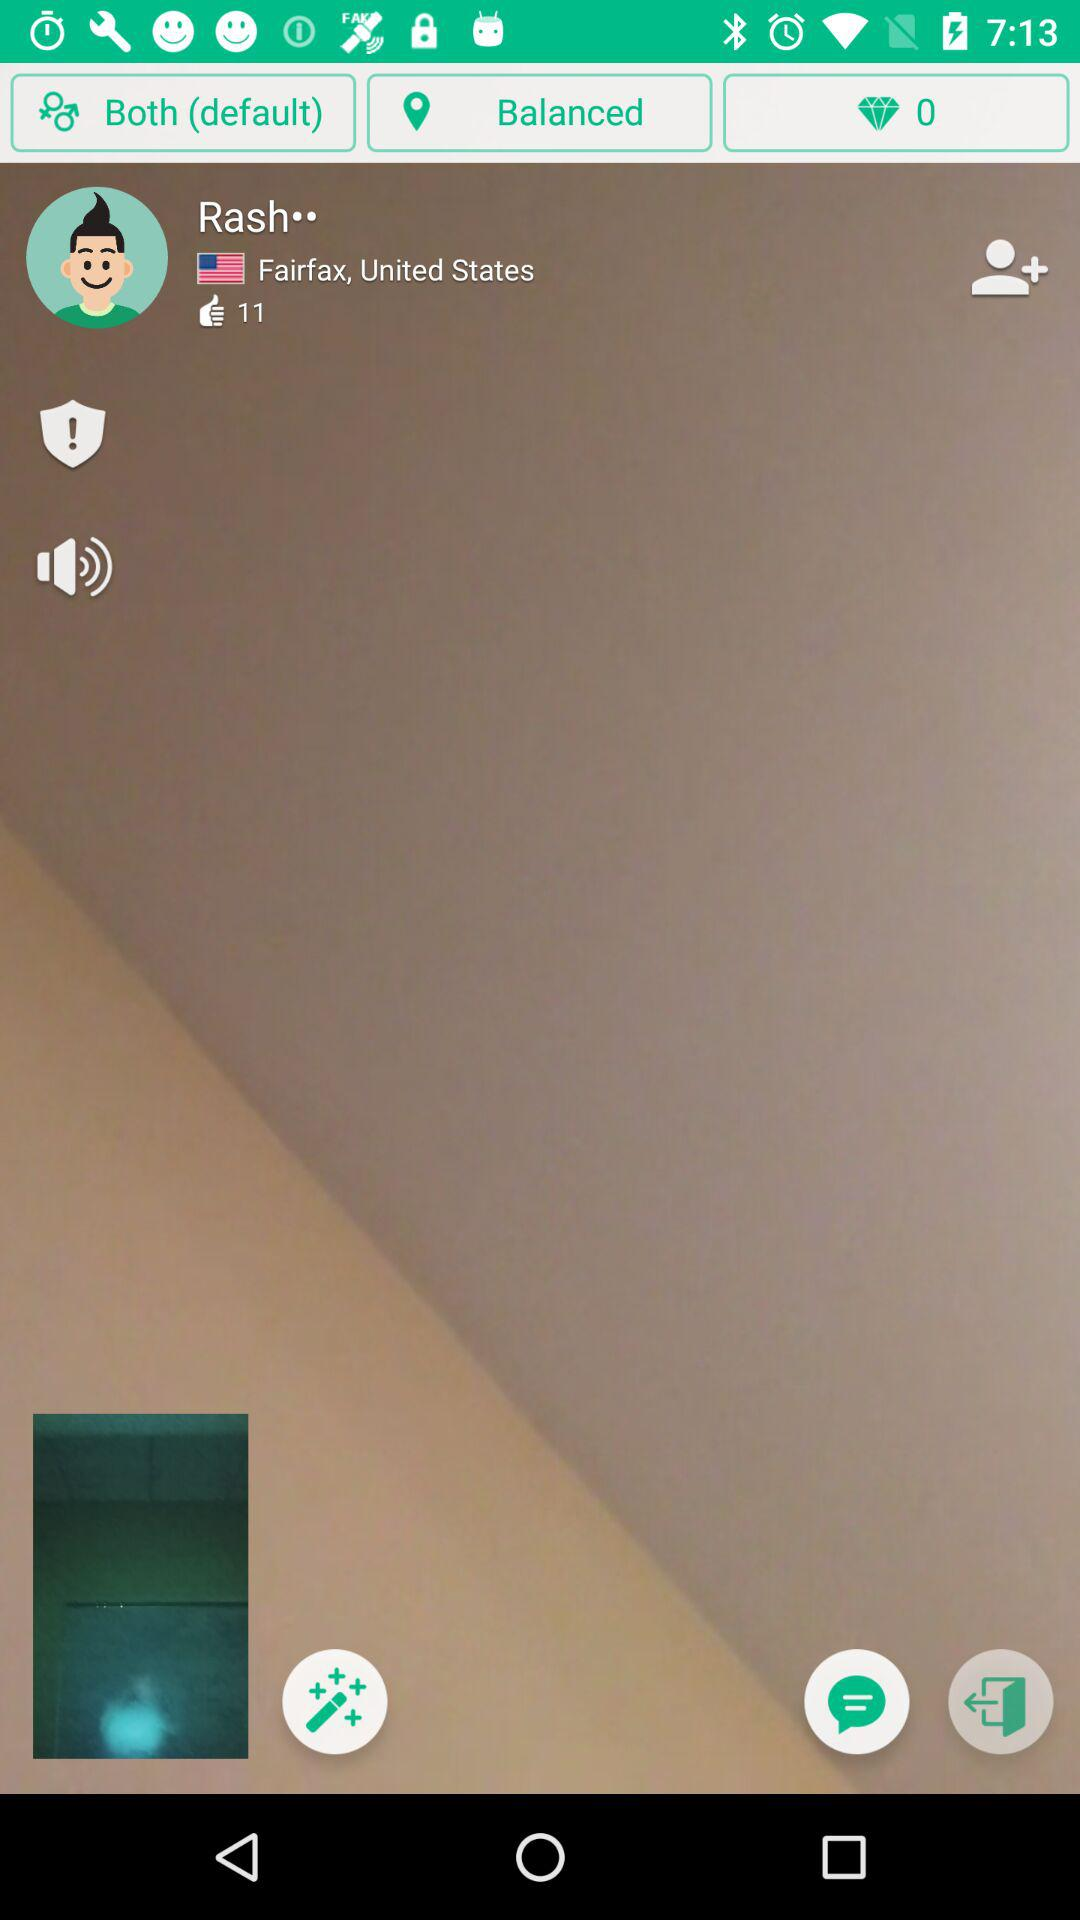How many diamonds are shown here? There are 0 diamonds. 